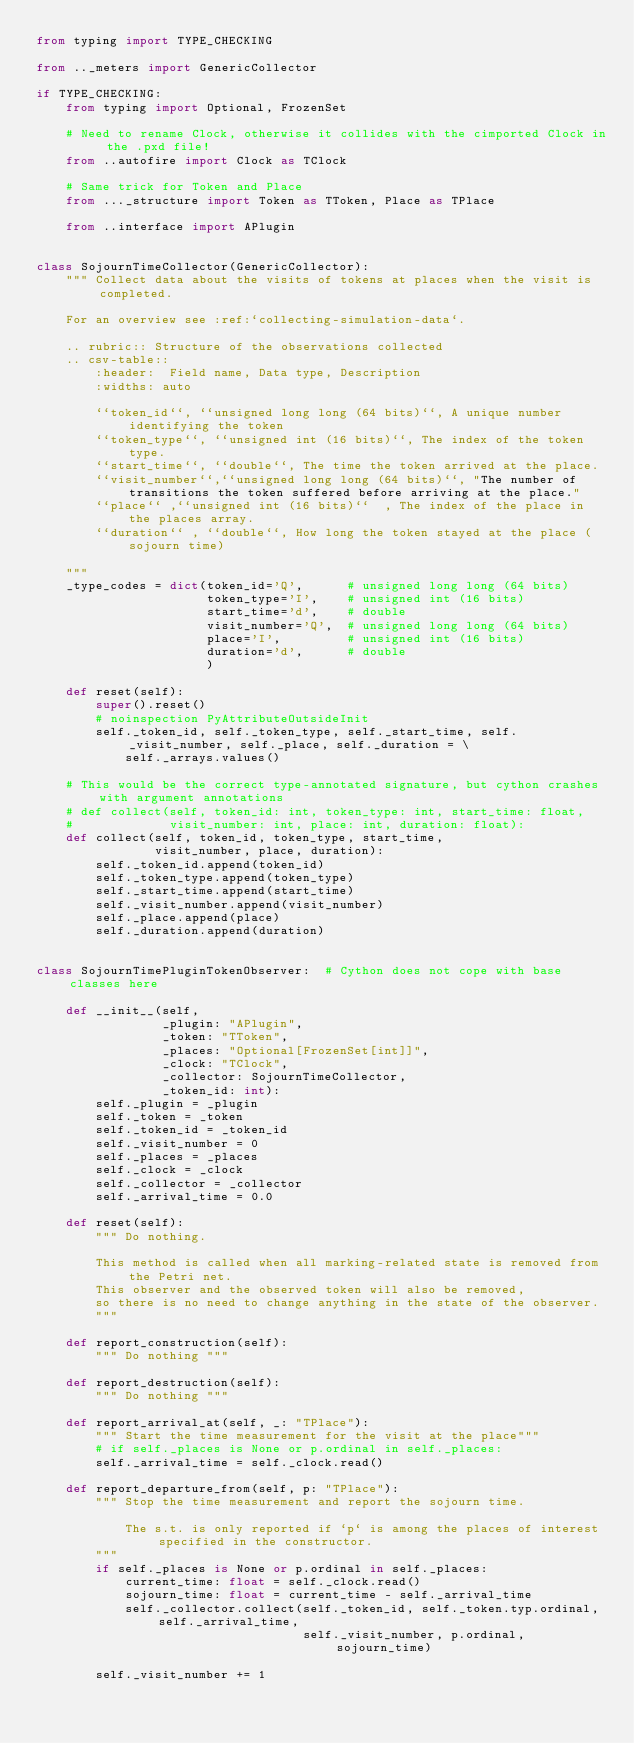<code> <loc_0><loc_0><loc_500><loc_500><_Python_>from typing import TYPE_CHECKING

from .._meters import GenericCollector

if TYPE_CHECKING:
    from typing import Optional, FrozenSet

    # Need to rename Clock, otherwise it collides with the cimported Clock in the .pxd file!
    from ..autofire import Clock as TClock

    # Same trick for Token and Place
    from ..._structure import Token as TToken, Place as TPlace

    from ..interface import APlugin


class SojournTimeCollector(GenericCollector):
    """ Collect data about the visits of tokens at places when the visit is completed.

    For an overview see :ref:`collecting-simulation-data`.

    .. rubric:: Structure of the observations collected
    .. csv-table::
        :header:  Field name, Data type, Description
        :widths: auto

        ``token_id``, ``unsigned long long (64 bits)``, A unique number identifying the token
        ``token_type``, ``unsigned int (16 bits)``, The index of the token type.
        ``start_time``, ``double``, The time the token arrived at the place.
        ``visit_number``,``unsigned long long (64 bits)``, "The number of transitions the token suffered before arriving at the place."
        ``place`` ,``unsigned int (16 bits)``  , The index of the place in the places array.
        ``duration`` , ``double``, How long the token stayed at the place (sojourn time)

    """
    _type_codes = dict(token_id='Q',      # unsigned long long (64 bits)
                       token_type='I',    # unsigned int (16 bits)
                       start_time='d',    # double
                       visit_number='Q',  # unsigned long long (64 bits)
                       place='I',         # unsigned int (16 bits)
                       duration='d',      # double
                       )

    def reset(self):
        super().reset()
        # noinspection PyAttributeOutsideInit
        self._token_id, self._token_type, self._start_time, self._visit_number, self._place, self._duration = \
            self._arrays.values()

    # This would be the correct type-annotated signature, but cython crashes with argument annotations
    # def collect(self, token_id: int, token_type: int, start_time: float,
    #             visit_number: int, place: int, duration: float):
    def collect(self, token_id, token_type, start_time,
                visit_number, place, duration):
        self._token_id.append(token_id)
        self._token_type.append(token_type)
        self._start_time.append(start_time)
        self._visit_number.append(visit_number)
        self._place.append(place)
        self._duration.append(duration)


class SojournTimePluginTokenObserver:  # Cython does not cope with base classes here

    def __init__(self,
                 _plugin: "APlugin",
                 _token: "TToken",
                 _places: "Optional[FrozenSet[int]]",
                 _clock: "TClock",
                 _collector: SojournTimeCollector,
                 _token_id: int):
        self._plugin = _plugin
        self._token = _token
        self._token_id = _token_id
        self._visit_number = 0
        self._places = _places
        self._clock = _clock
        self._collector = _collector
        self._arrival_time = 0.0

    def reset(self):
        """ Do nothing.

        This method is called when all marking-related state is removed from the Petri net.
        This observer and the observed token will also be removed,
        so there is no need to change anything in the state of the observer.
        """

    def report_construction(self):
        """ Do nothing """

    def report_destruction(self):
        """ Do nothing """

    def report_arrival_at(self, _: "TPlace"):
        """ Start the time measurement for the visit at the place"""
        # if self._places is None or p.ordinal in self._places:
        self._arrival_time = self._clock.read()

    def report_departure_from(self, p: "TPlace"):
        """ Stop the time measurement and report the sojourn time.

            The s.t. is only reported if `p` is among the places of interest specified in the constructor.
        """
        if self._places is None or p.ordinal in self._places:
            current_time: float = self._clock.read()
            sojourn_time: float = current_time - self._arrival_time
            self._collector.collect(self._token_id, self._token.typ.ordinal, self._arrival_time,
                                    self._visit_number, p.ordinal, sojourn_time)

        self._visit_number += 1
</code> 